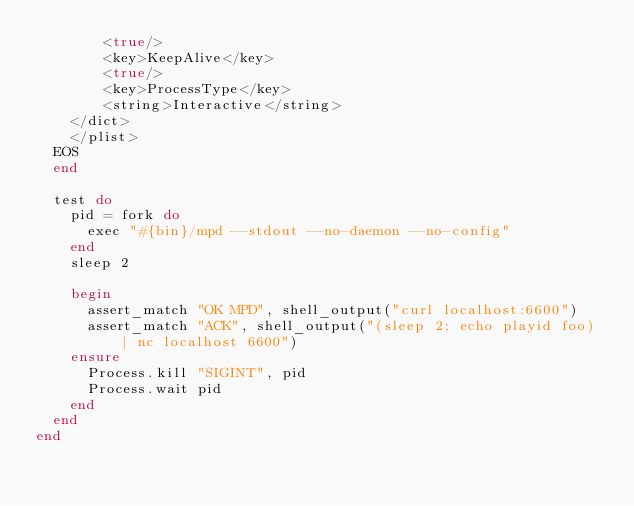<code> <loc_0><loc_0><loc_500><loc_500><_Ruby_>        <true/>
        <key>KeepAlive</key>
        <true/>
        <key>ProcessType</key>
        <string>Interactive</string>
    </dict>
    </plist>
  EOS
  end

  test do
    pid = fork do
      exec "#{bin}/mpd --stdout --no-daemon --no-config"
    end
    sleep 2

    begin
      assert_match "OK MPD", shell_output("curl localhost:6600")
      assert_match "ACK", shell_output("(sleep 2; echo playid foo) | nc localhost 6600")
    ensure
      Process.kill "SIGINT", pid
      Process.wait pid
    end
  end
end
</code> 